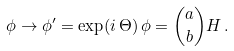<formula> <loc_0><loc_0><loc_500><loc_500>\phi \rightarrow \phi ^ { \prime } = \exp ( i \, \Theta ) \, \phi = { a \choose b } H \, .</formula> 